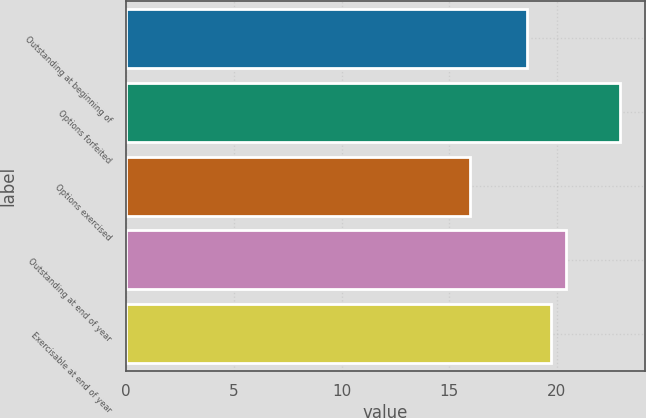Convert chart. <chart><loc_0><loc_0><loc_500><loc_500><bar_chart><fcel>Outstanding at beginning of<fcel>Options forfeited<fcel>Options exercised<fcel>Outstanding at end of year<fcel>Exercisable at end of year<nl><fcel>18.6<fcel>22.94<fcel>15.95<fcel>20.44<fcel>19.74<nl></chart> 